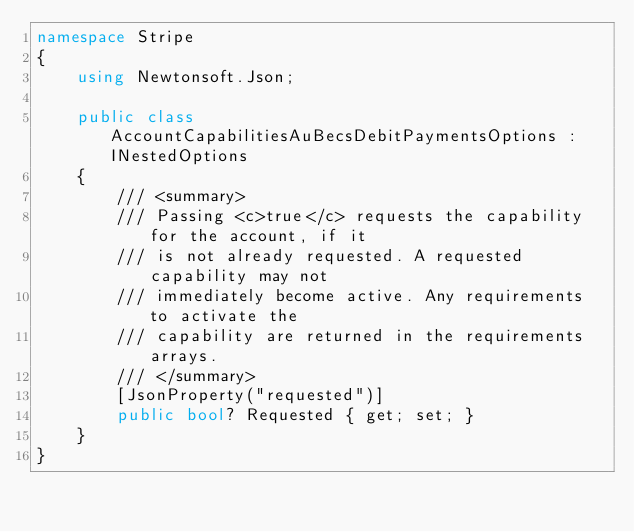<code> <loc_0><loc_0><loc_500><loc_500><_C#_>namespace Stripe
{
    using Newtonsoft.Json;

    public class AccountCapabilitiesAuBecsDebitPaymentsOptions : INestedOptions
    {
        /// <summary>
        /// Passing <c>true</c> requests the capability for the account, if it
        /// is not already requested. A requested capability may not
        /// immediately become active. Any requirements to activate the
        /// capability are returned in the requirements arrays.
        /// </summary>
        [JsonProperty("requested")]
        public bool? Requested { get; set; }
    }
}
</code> 